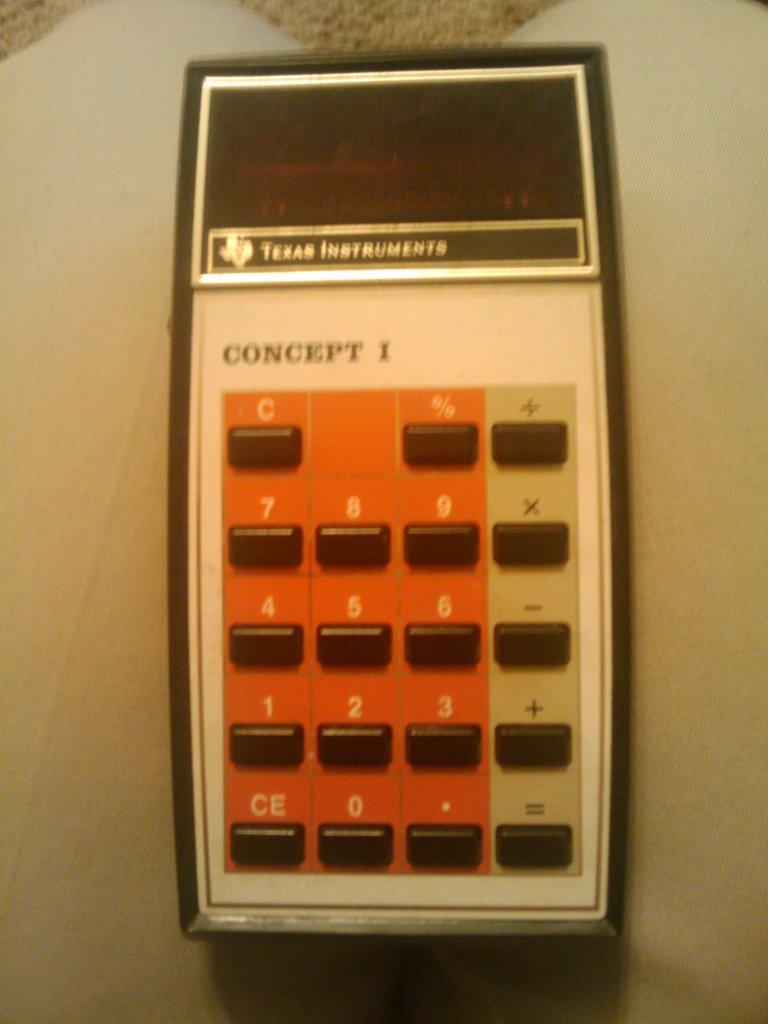<image>
Write a terse but informative summary of the picture. An old Texas instruments calculator with keboar numerals and function buttons 